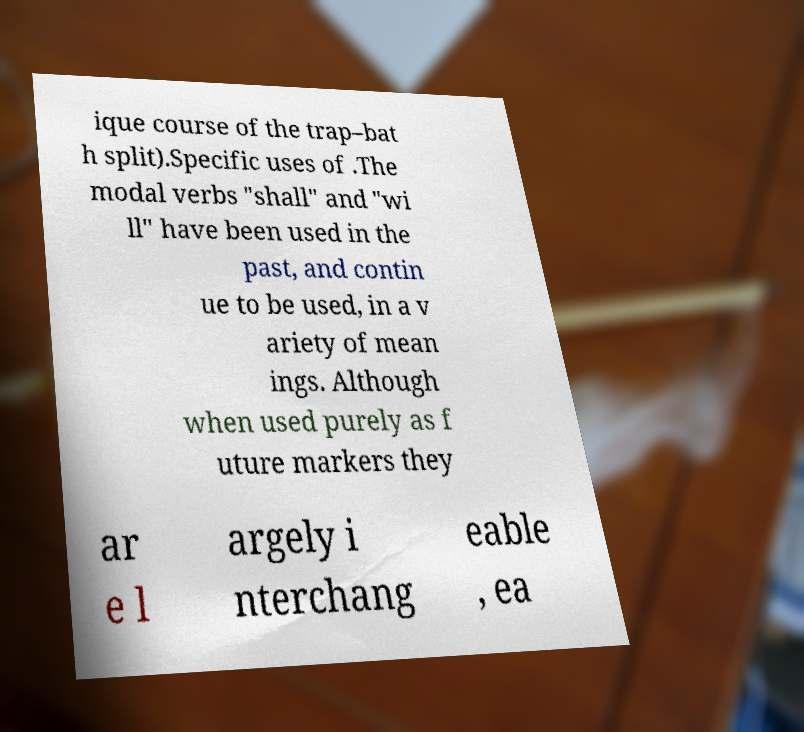Could you assist in decoding the text presented in this image and type it out clearly? ique course of the trap–bat h split).Specific uses of .The modal verbs "shall" and "wi ll" have been used in the past, and contin ue to be used, in a v ariety of mean ings. Although when used purely as f uture markers they ar e l argely i nterchang eable , ea 